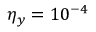Convert formula to latex. <formula><loc_0><loc_0><loc_500><loc_500>\eta _ { y } = 1 0 ^ { - 4 }</formula> 